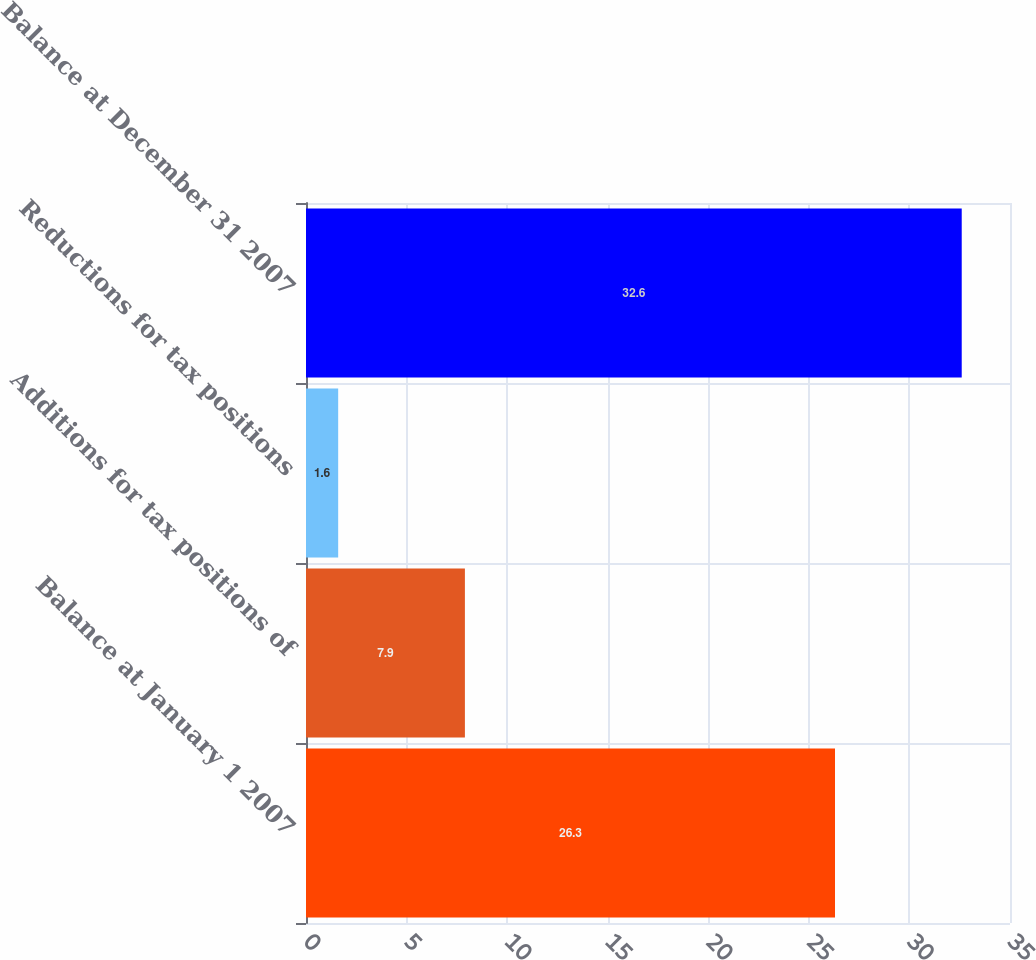Convert chart to OTSL. <chart><loc_0><loc_0><loc_500><loc_500><bar_chart><fcel>Balance at January 1 2007<fcel>Additions for tax positions of<fcel>Reductions for tax positions<fcel>Balance at December 31 2007<nl><fcel>26.3<fcel>7.9<fcel>1.6<fcel>32.6<nl></chart> 